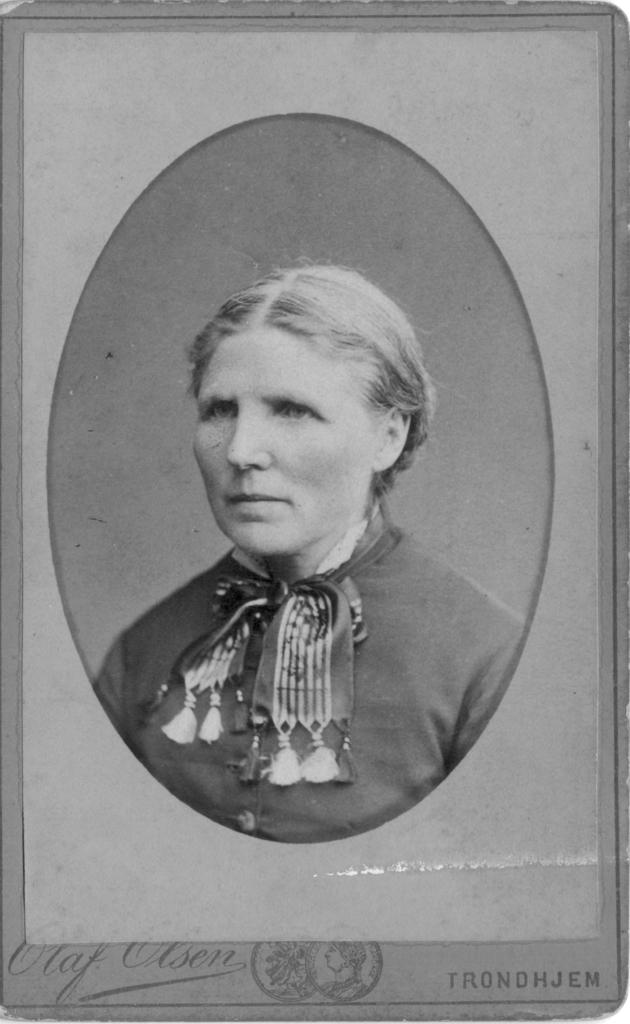Who is present in the image? There is a woman in the image. What is the woman wearing? The woman is wearing a black dress. What type of string is the woman holding during the meeting in the image? There is no meeting or string present in the image; it simply features a woman wearing a black dress. 